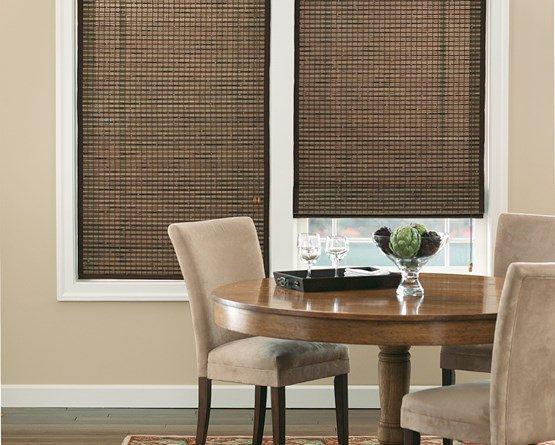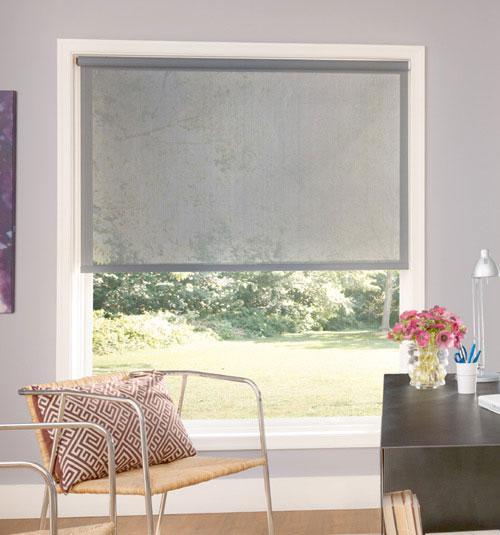The first image is the image on the left, the second image is the image on the right. Considering the images on both sides, is "There are exactly two window shades." valid? Answer yes or no. No. The first image is the image on the left, the second image is the image on the right. Evaluate the accuracy of this statement regarding the images: "A single brown chair is located near a window with a shade in the image on the right.". Is it true? Answer yes or no. Yes. 